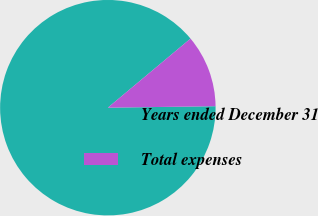Convert chart to OTSL. <chart><loc_0><loc_0><loc_500><loc_500><pie_chart><fcel>Years ended December 31<fcel>Total expenses<nl><fcel>89.14%<fcel>10.86%<nl></chart> 